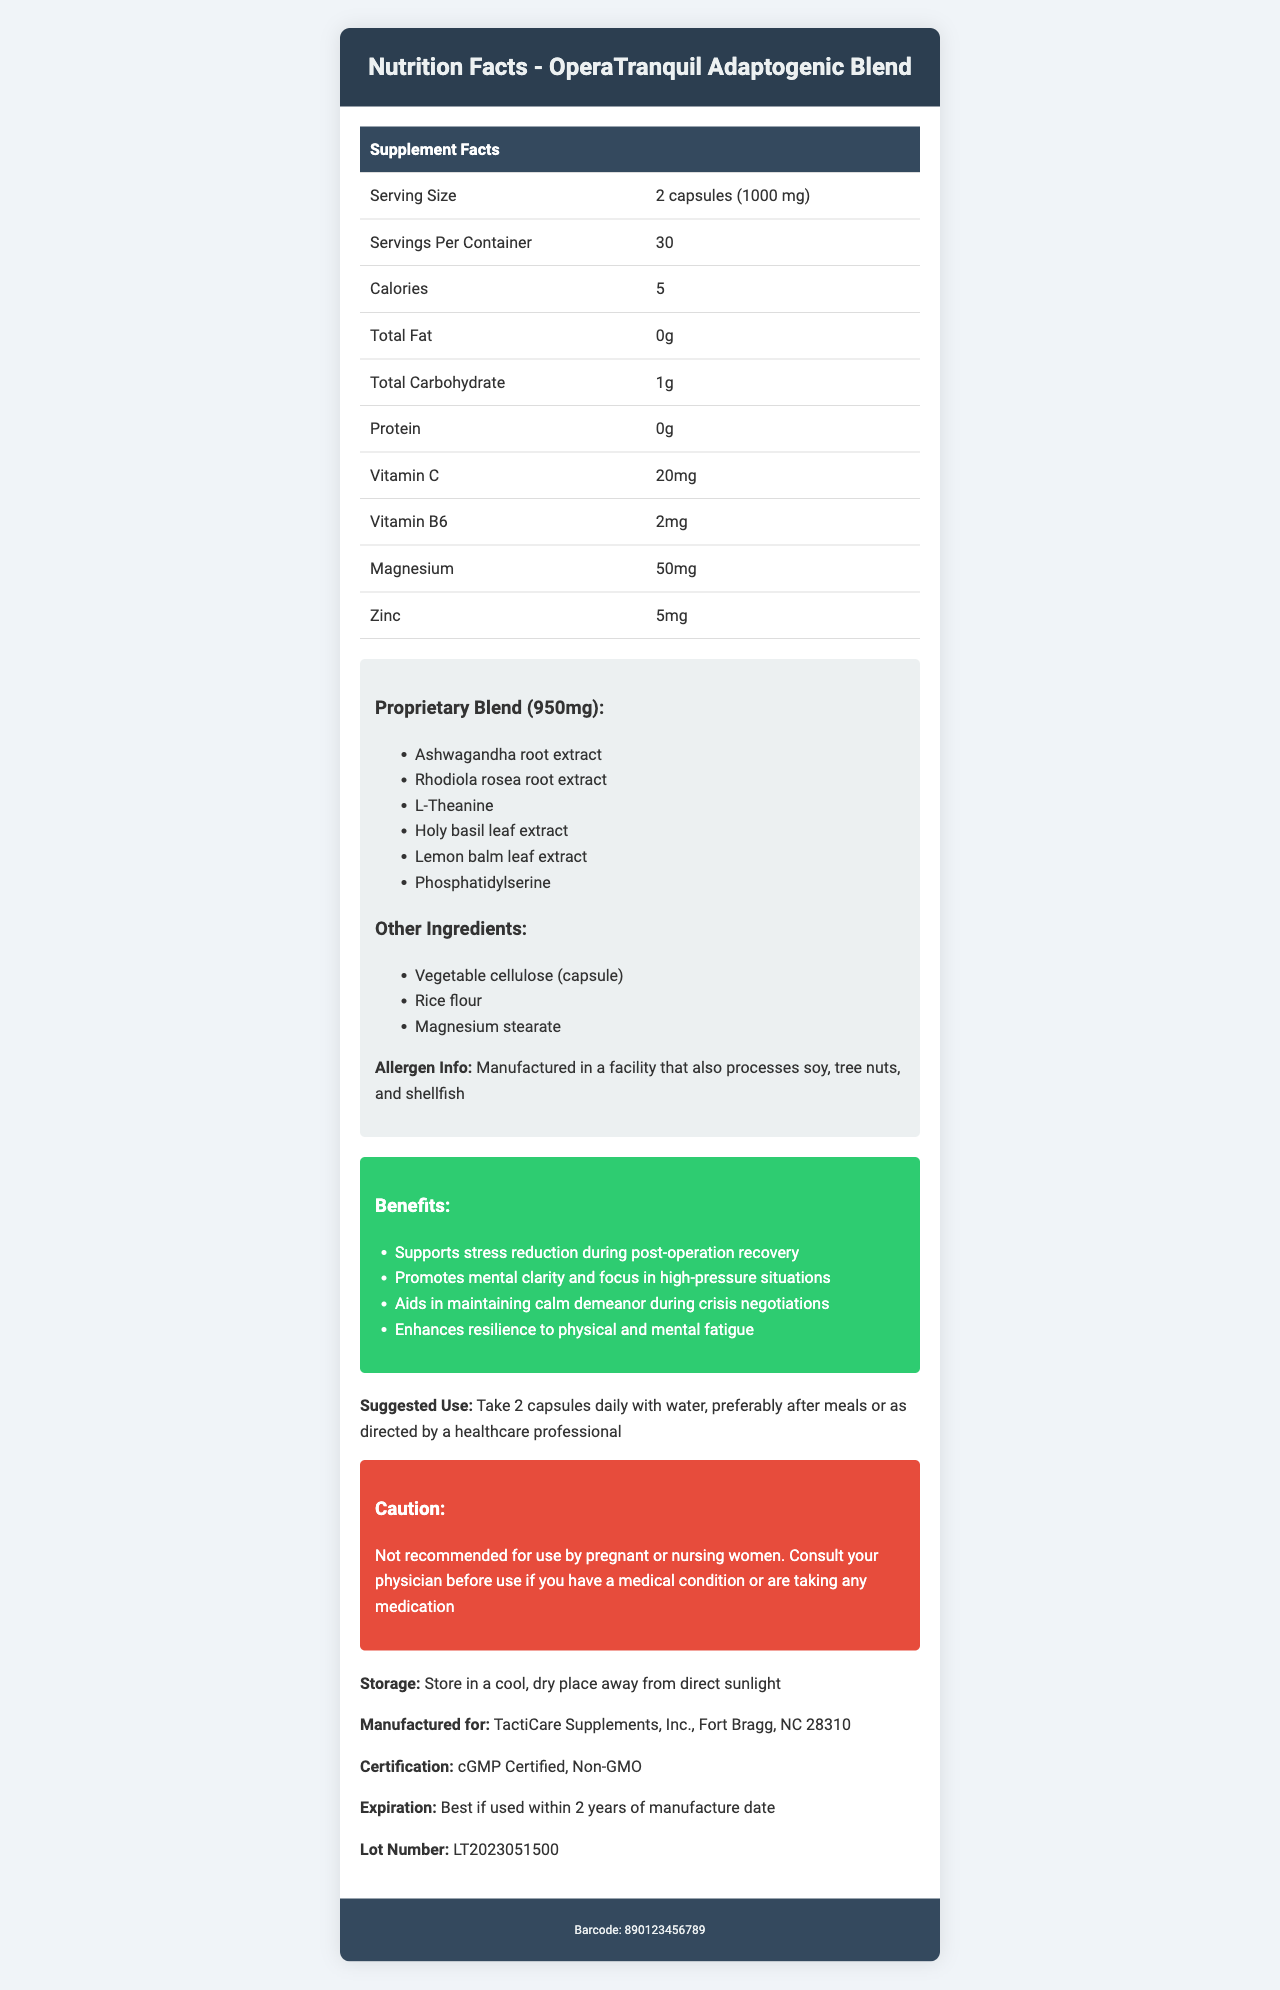what is the serving size of the OperaTranquil Adaptogenic Blend? The serving size is listed as "2 capsules (1000 mg)" in the document.
Answer: 2 capsules (1000 mg) how many servings are in the container? The document states that there are 30 servings per container.
Answer: 30 how many calories are in one serving? The nutrition facts table lists the calories as 5 per serving.
Answer: 5 what is the total amount of carbohydrate in a serving? The nutrition facts table lists the total carbohydrate as 1g per serving.
Answer: 1g who is the manufacturer of the product? The document lists the manufacturer as "TactiCare Supplements, Inc., Fort Bragg, NC 28310".
Answer: TactiCare Supplements, Inc., Fort Bragg, NC 28310 which ingredient is not part of the proprietary blend? A. Ashwagandha root extract B. Zinc C. Rhodiola rosea root extract Zinc is listed separately in the nutrition facts as 5mg, while the other ingredients are part of the proprietary blend.
Answer: B. Zinc which vitamin is included in greater quantity in each serving? A. Vitamin C B. Vitamin B6 C. Magnesium Vitamin C is listed as 20mg, which is greater than the 2mg of Vitamin B6.
Answer: A. Vitamin C does the product contain magnesium? The nutrition facts table lists magnesium as 50mg per serving.
Answer: Yes what are the benefits of using this product? The benefits section of the document lists these four benefits.
Answer: Supports stress reduction during post-operation recovery, Promotes mental clarity and focus in high-pressure situations, Aids in maintaining calm demeanor during crisis negotiations, Enhances resilience to physical and mental fatigue how should the product be stored? The document provides this specific storage instruction.
Answer: Store in a cool, dry place away from direct sunlight is the product suggested for use by pregnant or nursing women? The caution section specifically states that it is not recommended for use by pregnant or nursing women.
Answer: No what does the caution section recommend? The caution section advises consulting a physician if you have a medical condition or are taking medication.
Answer: Consult your physician before use if you have a medical condition or are taking any medication describe the main idea of the document. The document provides comprehensive information about the nutritional content and usage of the OperaTranquil Adaptogenic Blend, detailing its benefits, ingredients, and additional cautionary information for consumers.
Answer: The document is a detailed nutrition facts label for the OperaTranquil Adaptogenic Blend, providing information on serving size, nutritional content, proprietary blend, other ingredients, allergen info, benefits, suggested use, warnings, storage instructions, manufacturer details, certification, expiration date, and lot number. what is the exact manufacturing address of the product? The document only lists the manufacturer as "TactiCare Supplements, Inc., Fort Bragg, NC 28310" without an exact street address.
Answer: Cannot be determined 